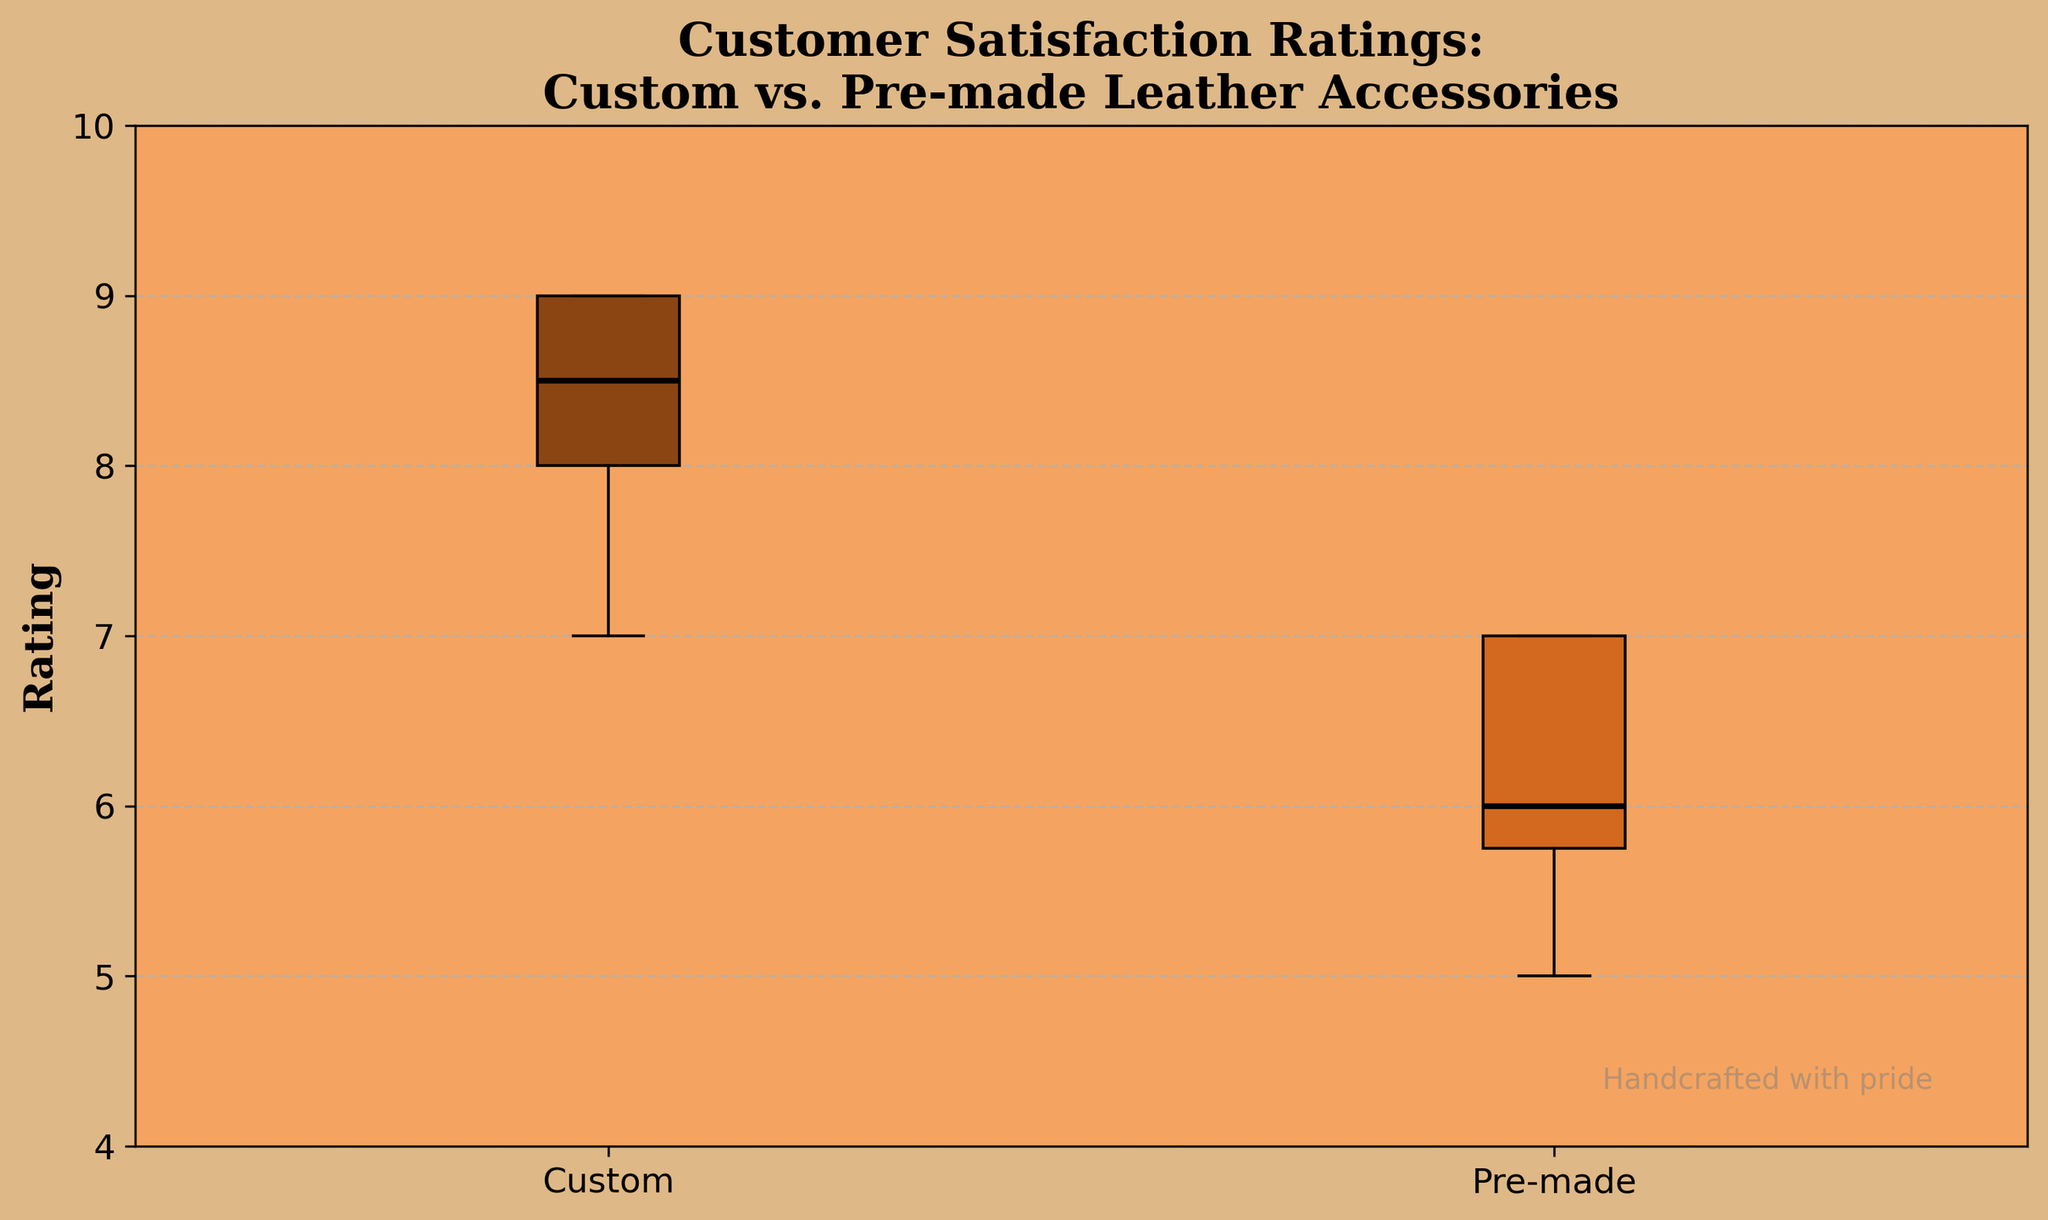What is the title of the plot? The title is provided at the top of the plot and usually describes what the figure represents. In this case, it mentions "Customer Satisfaction Ratings" for two types of leather accessories.
Answer: Customer Satisfaction Ratings: Custom vs. Pre-made Leather Accessories What are the labels for the two groups in the plot? The labels for the groups are found at the bottom of the box plots on the x-axis. They help differentiate the categories being compared.
Answer: Custom and Pre-made What is the median rating for Custom leather accessories? The median is indicated by the black line inside the box of the 'Custom' group. From the plot, we find this value visually.
Answer: 8 Which group shows a higher median rating? Comparing the median lines (black lines inside the boxes), we look for the higher value. The 'Custom' group has a median line higher than 'Pre-made'.
Answer: Custom What is the range of ratings for Pre-made leather accessories? The range is the difference between the highest and lowest points within the whiskers for the 'Pre-made' group. The highest is 7 and the lowest is 5.
Answer: 2 How does the interquartile range (IQR) of Custom compare to Pre-made? The IQR is the difference between the upper and lower quartiles (top and bottom edges of the box). Visually inspect the IQR for both groups and compare them.
Answer: Custom has a larger IQR than Pre-made What is the lowest rating recorded for Pre-made leather accessories? The lowest rating is shown at the bottom of the whisker for the 'Pre-made' group.
Answer: 5 Are there any outliers in either group? Outliers are typically marked by separate points outside the whiskers. The plot should be inspected for any such points in both groups.
Answer: No Which group has more variability in customer satisfaction ratings? Variability is usually indicated by the length of the box and whiskers. The longer these are, the more variability. Compare the lengths for both groups.
Answer: Custom What is the highest rating recorded for Custom leather accessories? The highest rating is shown at the top of the whisker for the 'Custom' group.
Answer: 9 